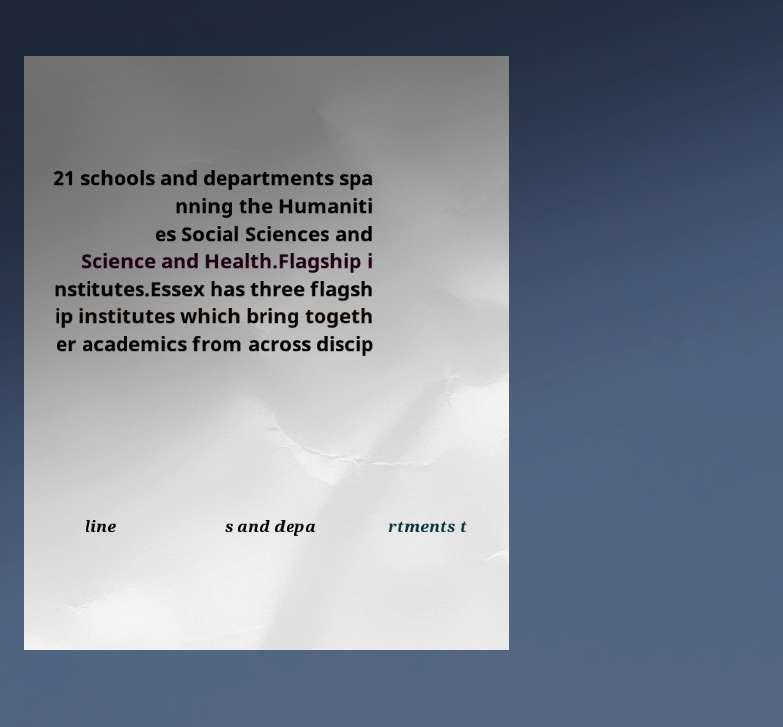There's text embedded in this image that I need extracted. Can you transcribe it verbatim? 21 schools and departments spa nning the Humaniti es Social Sciences and Science and Health.Flagship i nstitutes.Essex has three flagsh ip institutes which bring togeth er academics from across discip line s and depa rtments t 